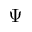Convert formula to latex. <formula><loc_0><loc_0><loc_500><loc_500>\Psi</formula> 